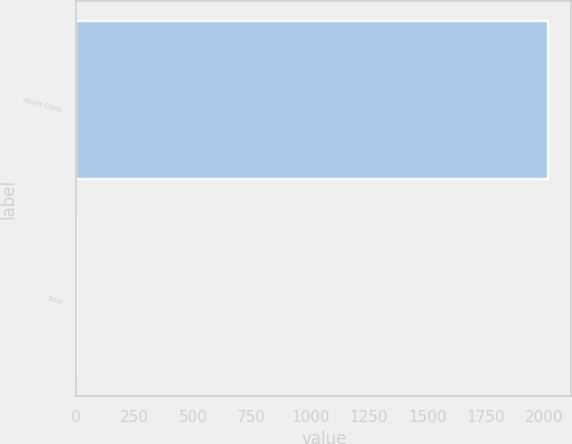Convert chart to OTSL. <chart><loc_0><loc_0><loc_500><loc_500><bar_chart><fcel>Asset Class<fcel>Total<nl><fcel>2015<fcel>4<nl></chart> 